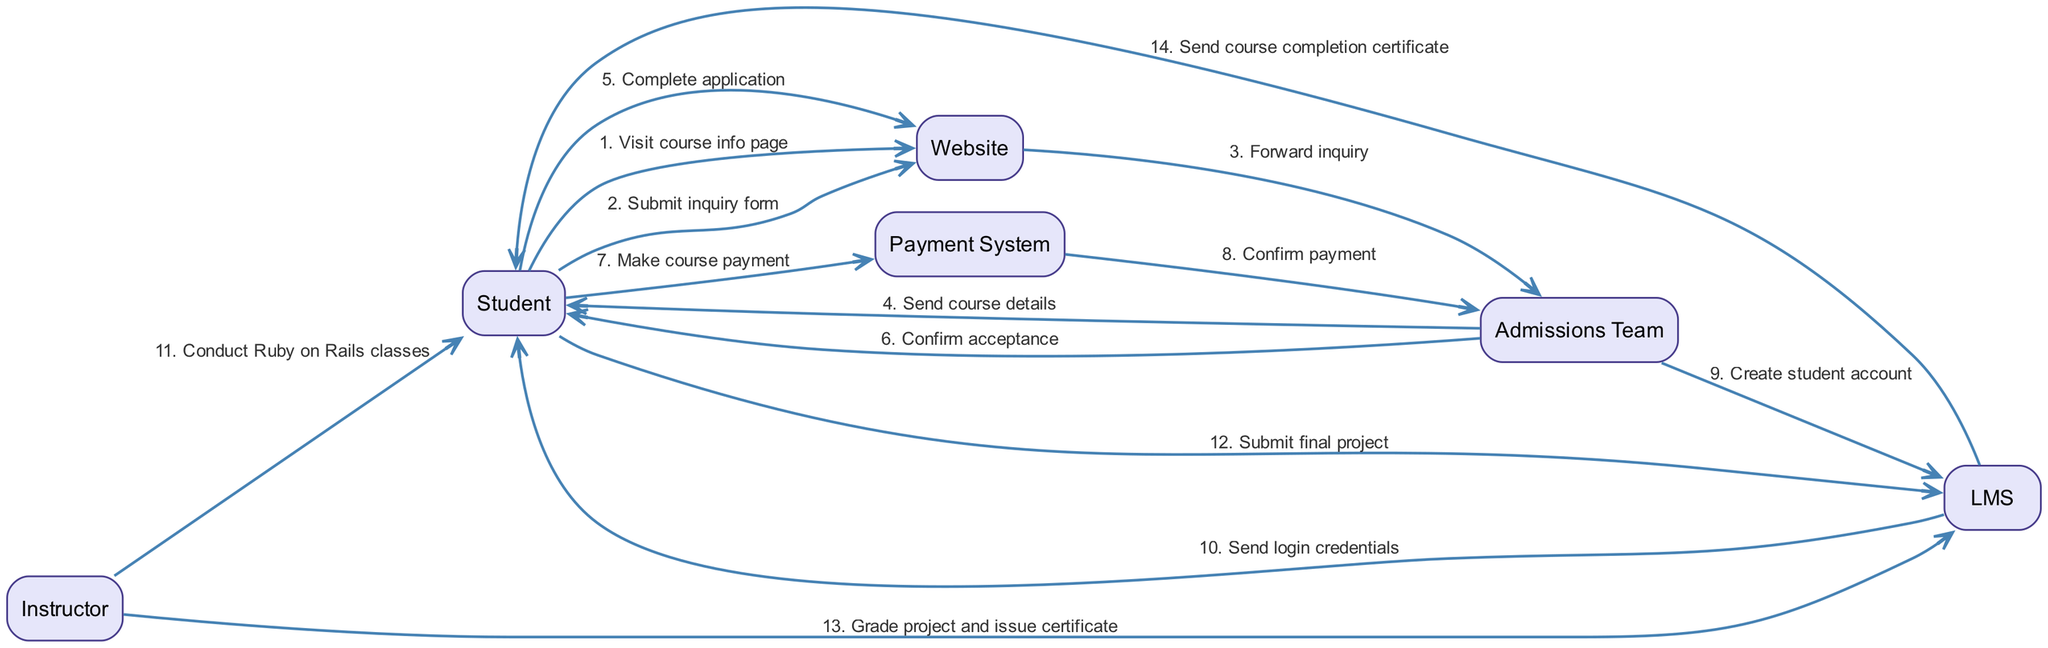What is the first interaction in the enrollment process? The first interaction is when the Student visits the course info page on the Website. This is indicated as the initial message in the sequence, setting the stage for the subsequent actions.
Answer: Visit course info page How many actors are involved in the diagram? Counting the unique roles in the interactions, we have six actors: Student, Website, Admissions Team, Payment System, Instructor, and LMS. This totals to six distinct nodes in the diagram.
Answer: 6 Which actor confirms the student's acceptance into the course? The Admissions Team is responsible for confirming the student's acceptance after the application process. This is represented as a direct message from the Admissions Team to the Student confirming acceptance.
Answer: Admissions Team What action takes place after the Student makes a course payment? Once the Student makes a course payment, the Payment System confirms that payment to the Admissions Team. This step, indicated by the message from Payment System to Admissions Team, is critical for proceeding with the enrollment.
Answer: Confirm payment How many messages are sent from the Admissions Team to the Student? In the diagram, the Admissions Team sends two messages to the Student: one for sending course details and another for confirming acceptance. Counting both gives us a total of two messages from the Admissions Team to the Student.
Answer: 2 Which actor sends the course completion certificate to the Student? The LMS sends the course completion certificate to the Student, completing the enrollment process and validating the student's achievement in the course. This is the final message in the sequence that signifies course completion.
Answer: LMS What is the last interaction that a Student has in the enrollment process? The last interaction recorded for the Student is when they receive the course completion certificate from the LMS. This action concludes the sequence of events that the diagram depicts for the enrollment process.
Answer: Send course completion certificate Who is responsible for grading the final project? The Instructor is responsible for grading the final project, as indicated by the interaction that involves the Instructor sending the grades to the LMS after the Student submits their project. This shows the role of the Instructor in assessing the course completion criteria.
Answer: Instructor What does the Student submit to complete their course? The Student submits the final project as a requirement to complete the course, which is a key milestone in the learning process as shown in the interactions within the diagram.
Answer: Submit final project 